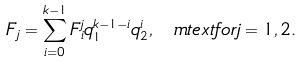Convert formula to latex. <formula><loc_0><loc_0><loc_500><loc_500>F _ { j } = \sum _ { i = 0 } ^ { k - 1 } F _ { i } ^ { j } q _ { 1 } ^ { k - 1 - i } q _ { 2 } ^ { i } , \ m t e x t { f o r } j = 1 , 2 .</formula> 